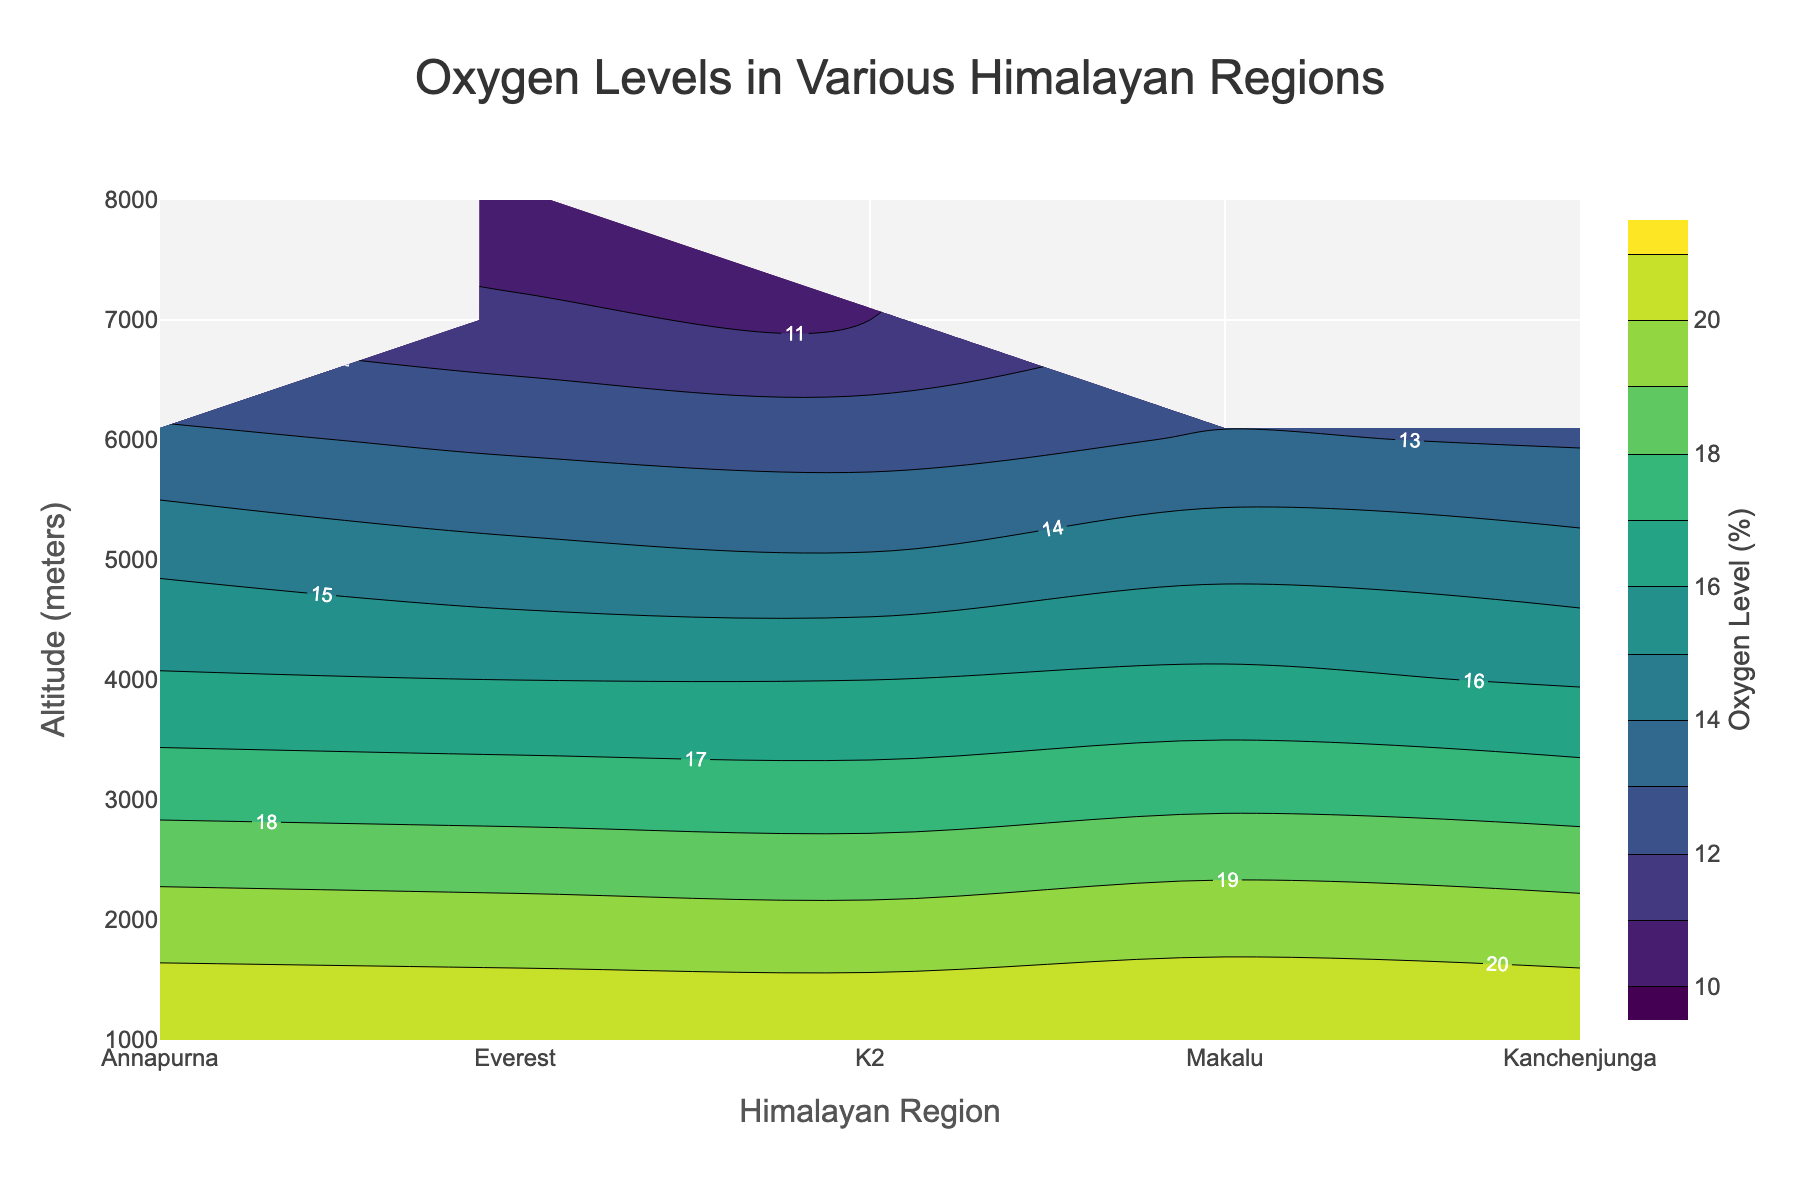What is the title of the plot? The title of the plot is displayed at the top and centered in large font. It summarizes what the figure represents.
Answer: Oxygen Levels in Various Himalayan Regions Which Himalayan region has the highest oxygen level at 6000 meters? By examining the contour plot at the altitude of 6000 meters, observe the oxygen levels for each region.
Answer: Annapurna How does the oxygen level differ between 1000 meters and 4000 meters in the Everest region? Locate the Everest region on the contour plot and compare the oxygen levels at 1000 meters and 4000 meters. Perform the subtraction: 20.9 - 16.0.
Answer: 4.9% At what altitude does the Kanchenjunga region first show an oxygen level below 15%? Track the contours for the Kanchenjunga region and identify the altitude where the oxygen level dips below 15%.
Answer: 5000 meters Which two regions show similar oxygen levels at an altitude of 5000 meters? Compare oxygen levels among all regions at 5000 meters and identify the two regions with close values.
Answer: Makalu and Everest What is the range of oxygen levels displayed in the color bar? The range is indicated on the color bar beside the contour plot, showing the minimum and maximum levels of oxygen.
Answer: 10% to 21% Which region shows the steepest decline in oxygen levels as altitude increases? By observing the contour plot, identify which region has the closely spaced contours, indicating a rapid decline.
Answer: Everest Is the oxygen level at 7000 meters in K2 higher or lower than that in Everest? Compare the oxygen levels of both regions at 7000 meters as represented in the contour plot.
Answer: Higher in K2 What is the general trend of oxygen level changes with increasing altitude in all regions? Examine the contour plots across all regions to understand the overarching pattern as altitude increases.
Answer: Decreases What is the color representation of an oxygen level around 13% on the contour plot? Identify the color corresponding to 13% by looking at the color bar next to the contour plot.
Answer: Green 